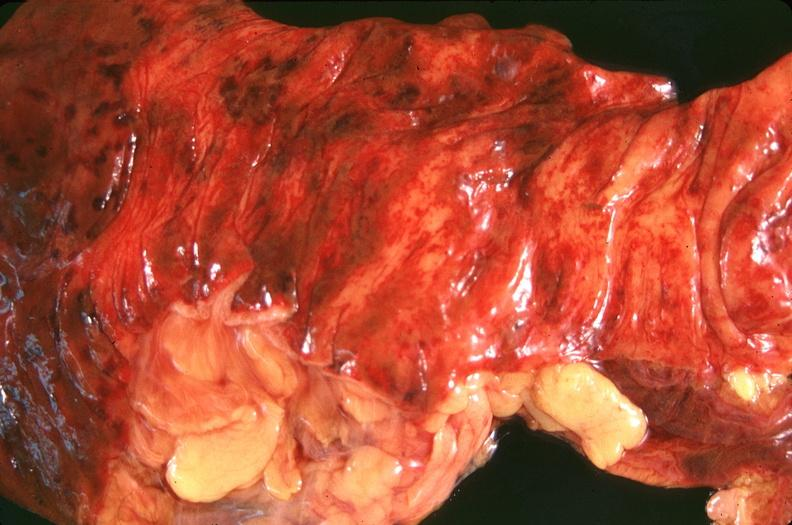where does this belong to?
Answer the question using a single word or phrase. Gastrointestinal system 